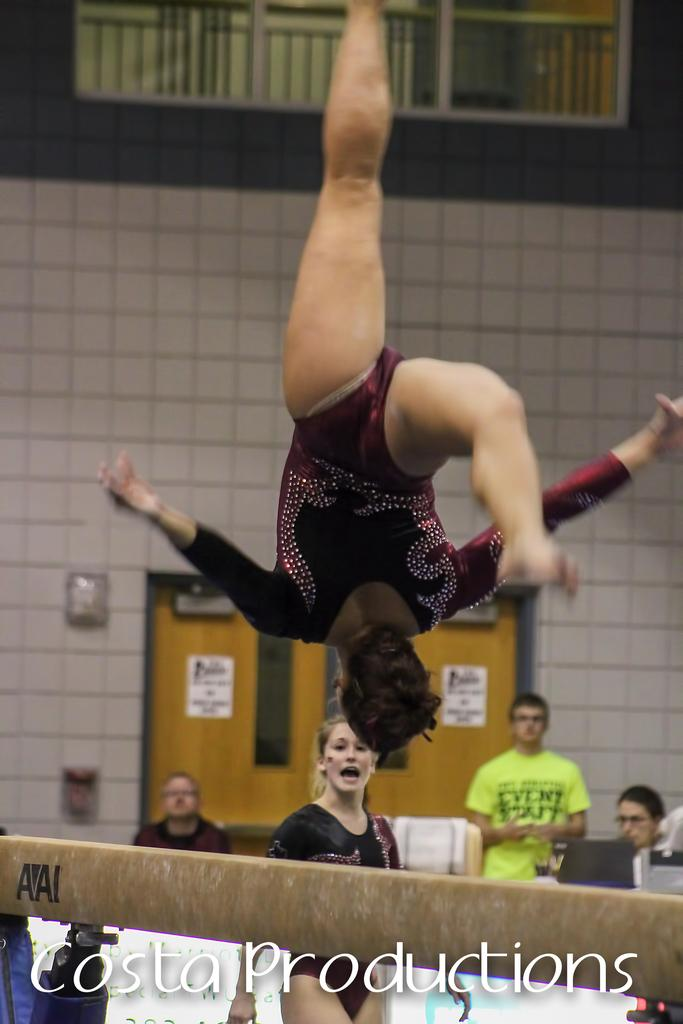Who is the main subject in the image? There is a woman in the image. What is the woman doing in the image? The woman is flipping in the air. What can be seen in the background of the image? There is a wall in the background of the image. Are there any other people present in the image? Yes, there are people in the image. Can you see any yaks in the image? No, there are no yaks present in the image. Are there any fairies flying around the woman in the image? No, there are no fairies present in the image. 